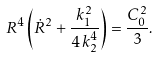Convert formula to latex. <formula><loc_0><loc_0><loc_500><loc_500>R ^ { 4 } \left ( \dot { R } ^ { 2 } + { \frac { k _ { 1 } ^ { 2 } } { 4 \, k _ { 2 } ^ { 4 } } } \right ) = { \frac { C _ { 0 } ^ { 2 } } 3 } .</formula> 